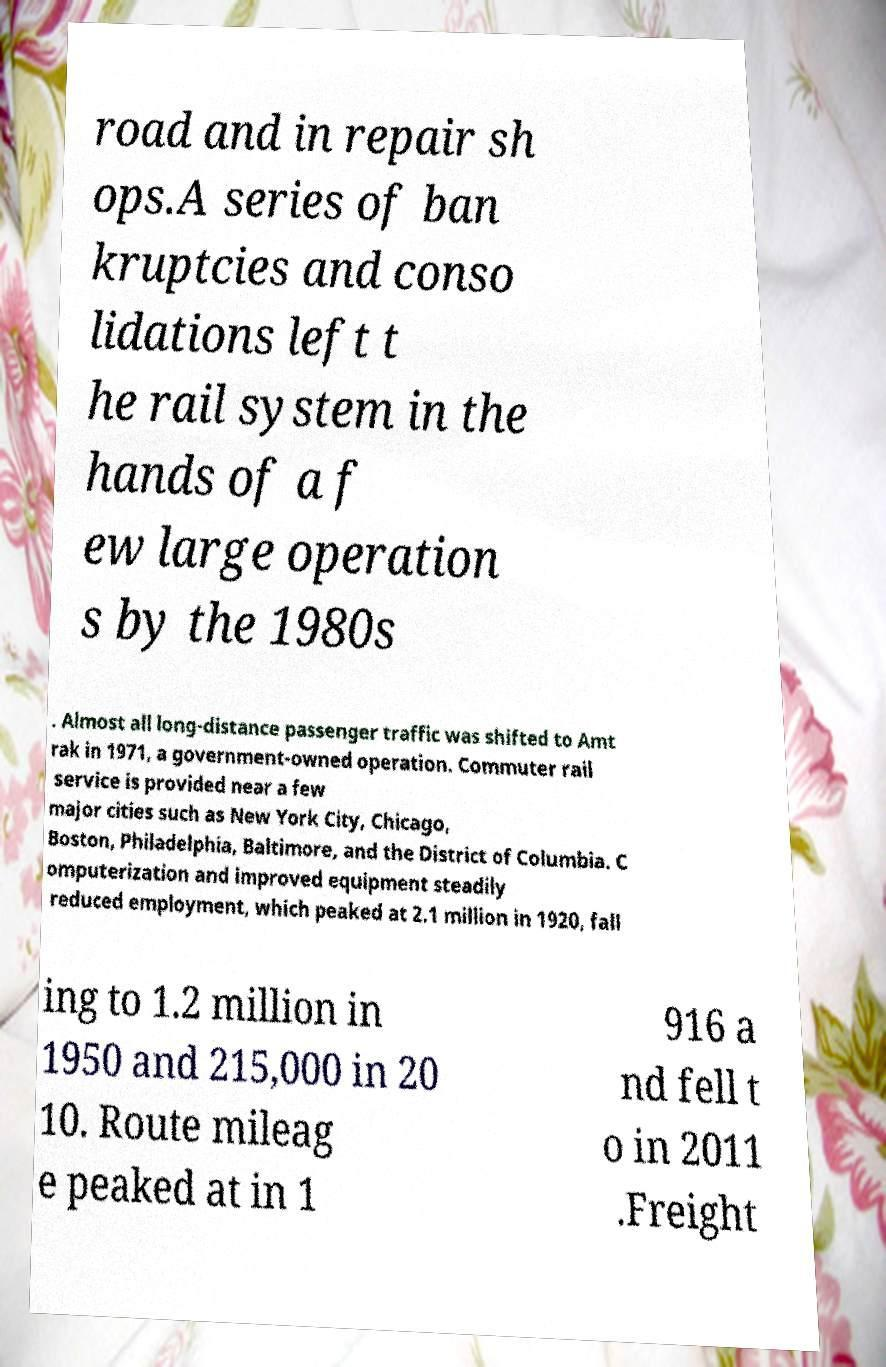Please identify and transcribe the text found in this image. road and in repair sh ops.A series of ban kruptcies and conso lidations left t he rail system in the hands of a f ew large operation s by the 1980s . Almost all long-distance passenger traffic was shifted to Amt rak in 1971, a government-owned operation. Commuter rail service is provided near a few major cities such as New York City, Chicago, Boston, Philadelphia, Baltimore, and the District of Columbia. C omputerization and improved equipment steadily reduced employment, which peaked at 2.1 million in 1920, fall ing to 1.2 million in 1950 and 215,000 in 20 10. Route mileag e peaked at in 1 916 a nd fell t o in 2011 .Freight 